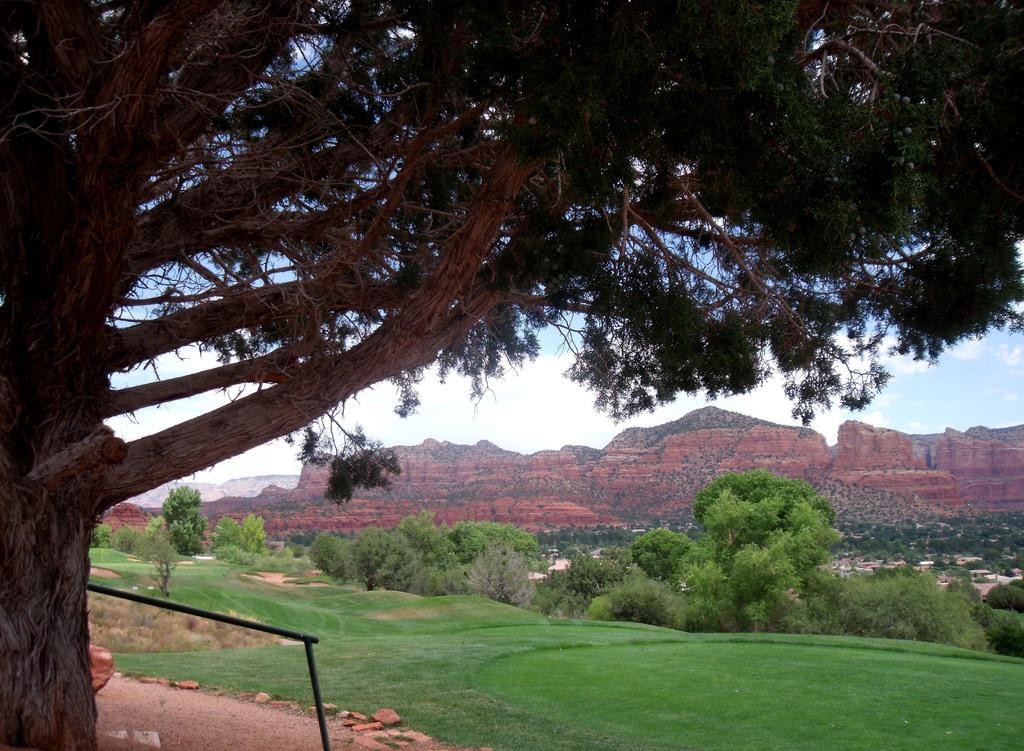Can you describe this image briefly? In this image a group of trees are there and a group of hills together ,and we can see a grassy land. 